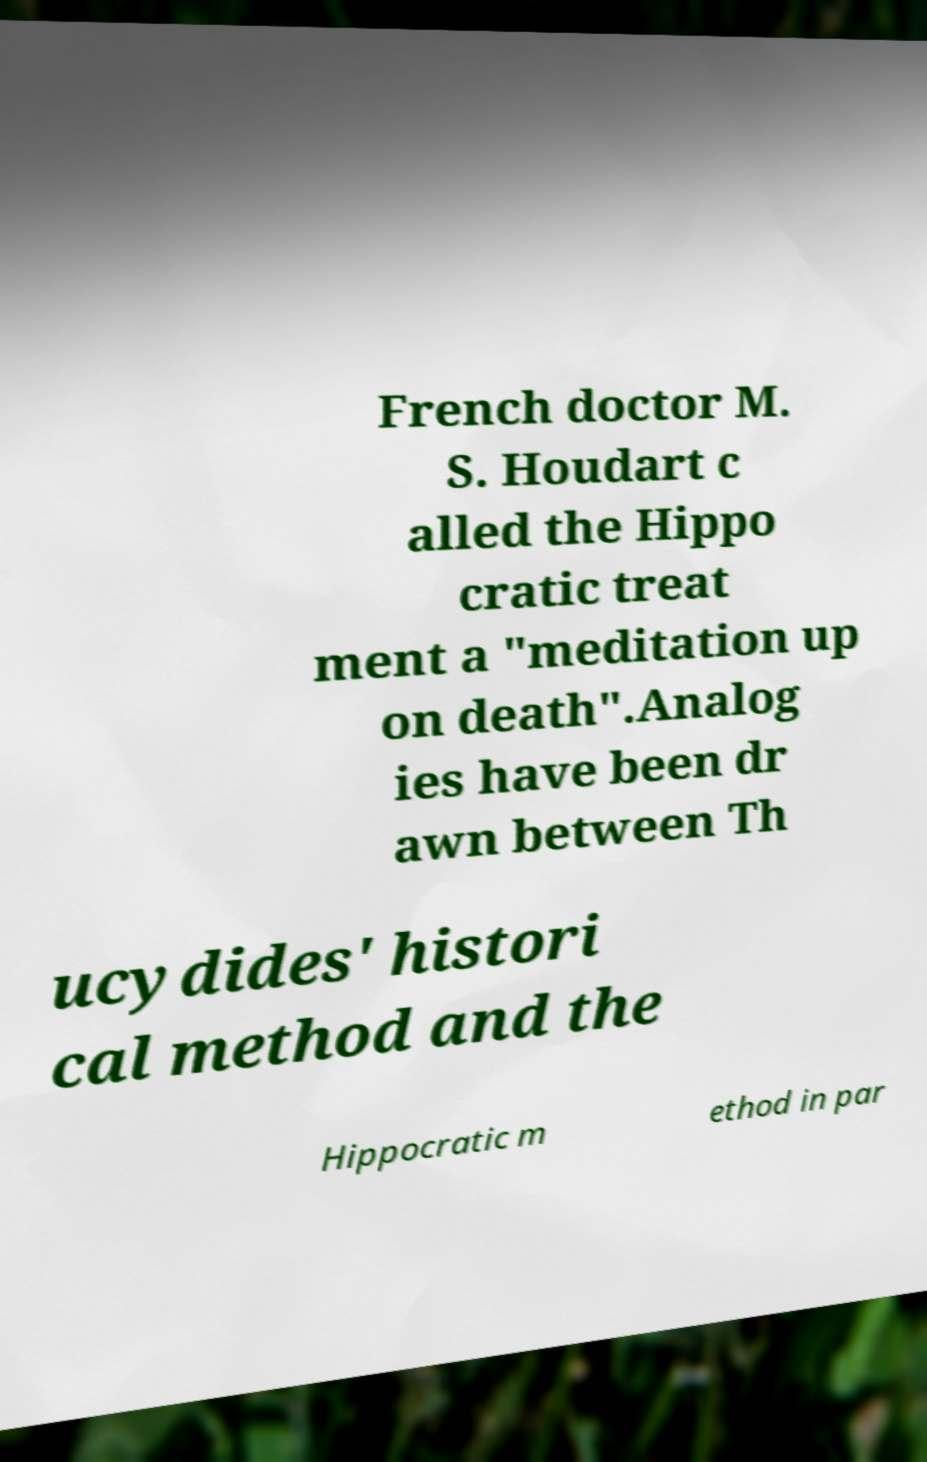Can you accurately transcribe the text from the provided image for me? French doctor M. S. Houdart c alled the Hippo cratic treat ment a "meditation up on death".Analog ies have been dr awn between Th ucydides' histori cal method and the Hippocratic m ethod in par 